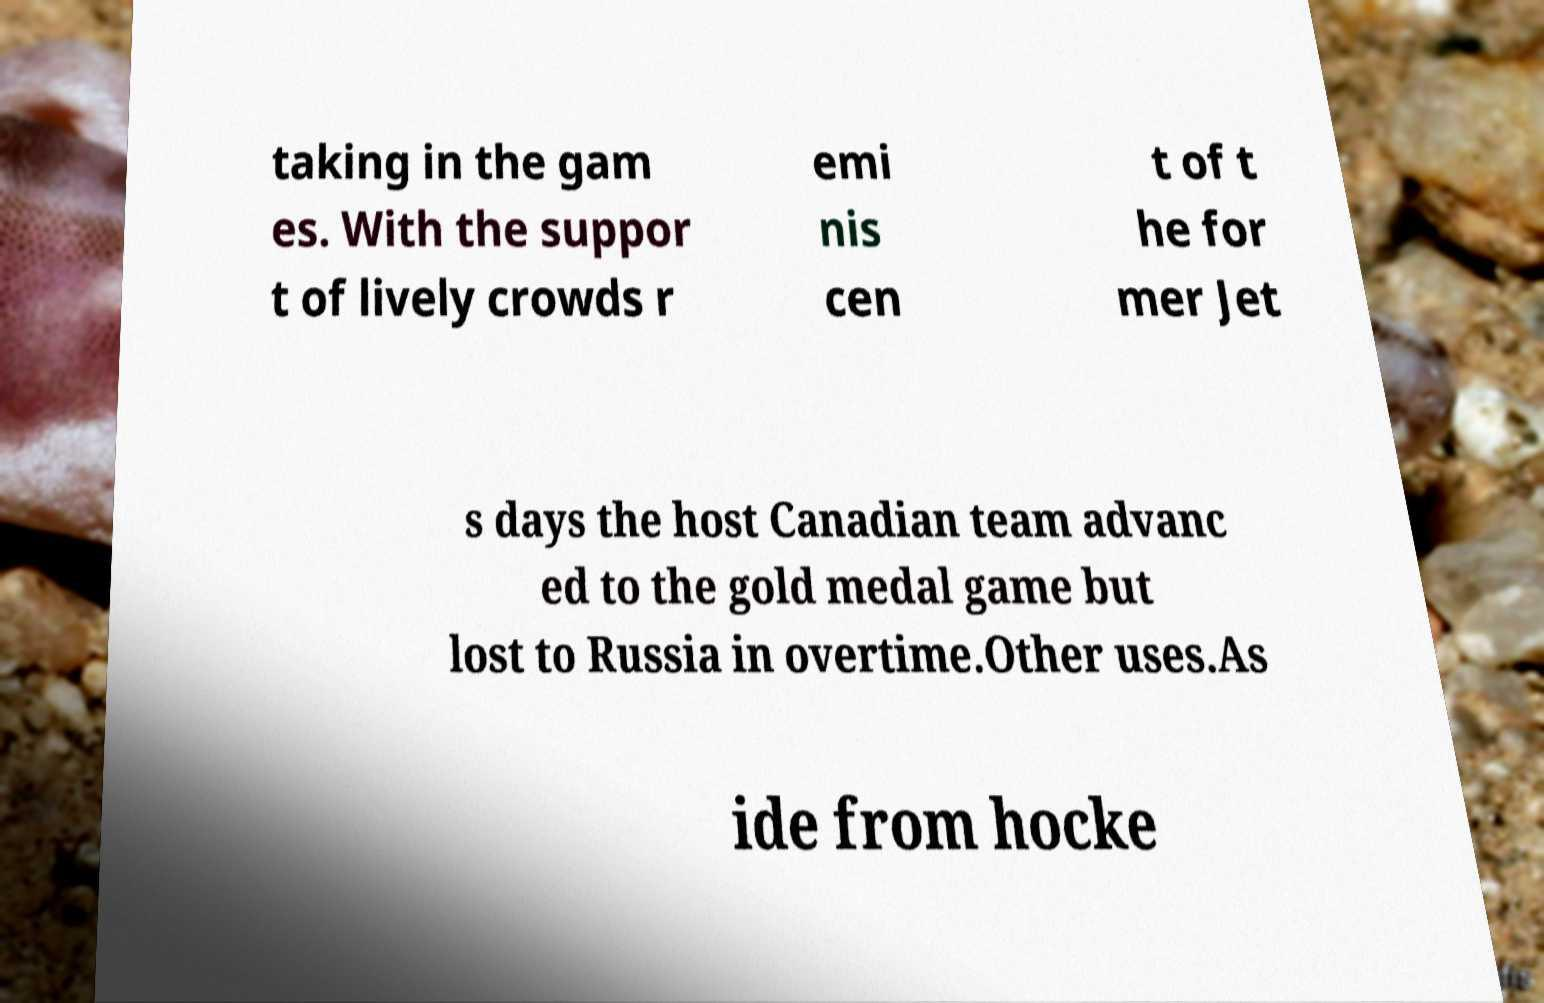Please read and relay the text visible in this image. What does it say? taking in the gam es. With the suppor t of lively crowds r emi nis cen t of t he for mer Jet s days the host Canadian team advanc ed to the gold medal game but lost to Russia in overtime.Other uses.As ide from hocke 